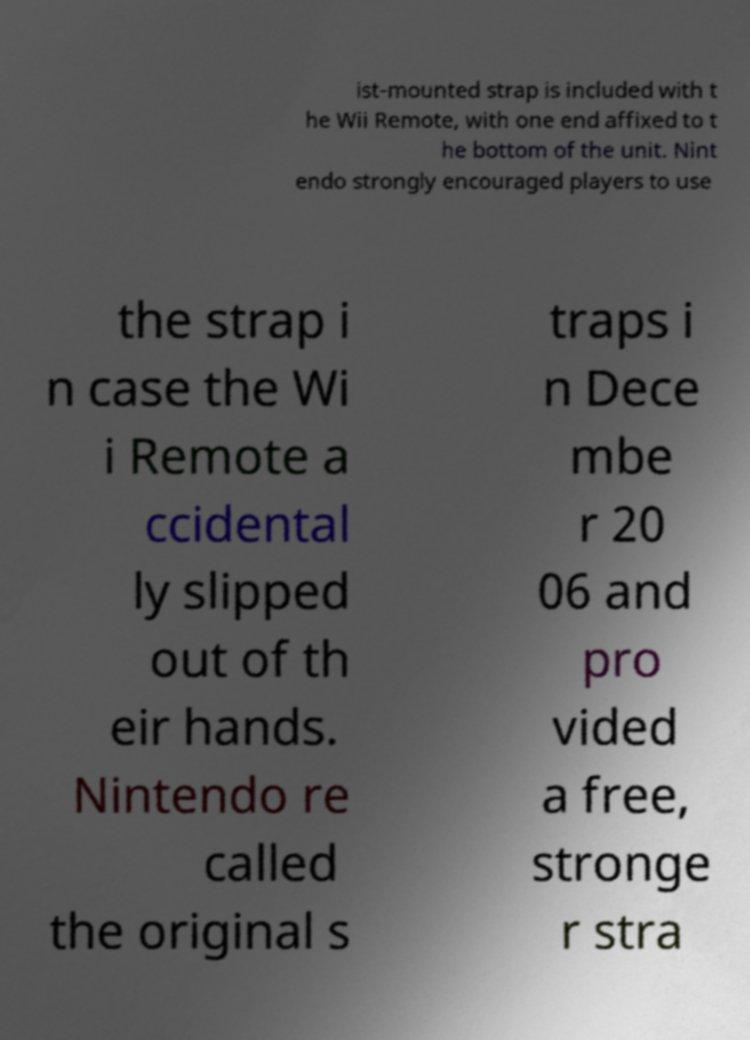Can you read and provide the text displayed in the image?This photo seems to have some interesting text. Can you extract and type it out for me? ist-mounted strap is included with t he Wii Remote, with one end affixed to t he bottom of the unit. Nint endo strongly encouraged players to use the strap i n case the Wi i Remote a ccidental ly slipped out of th eir hands. Nintendo re called the original s traps i n Dece mbe r 20 06 and pro vided a free, stronge r stra 